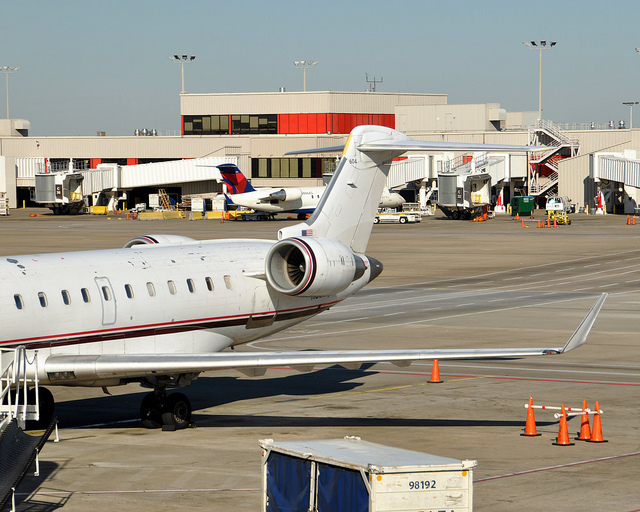Please transcribe the text in this image. 98192 